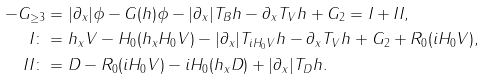<formula> <loc_0><loc_0><loc_500><loc_500>- G _ { \geq 3 } & = | \partial _ { x } | \phi - G ( h ) \phi - | \partial _ { x } | T _ { B } h - \partial _ { x } T _ { V } h + G _ { 2 } = I + I I , \\ I \colon & = h _ { x } V - H _ { 0 } ( h _ { x } H _ { 0 } V ) - | \partial _ { x } | T _ { i H _ { 0 } V } h - \partial _ { x } T _ { V } h + G _ { 2 } + R _ { 0 } ( i H _ { 0 } V ) , \\ I I \colon & = D - R _ { 0 } ( i H _ { 0 } V ) - i H _ { 0 } ( h _ { x } D ) + | \partial _ { x } | T _ { D } h .</formula> 